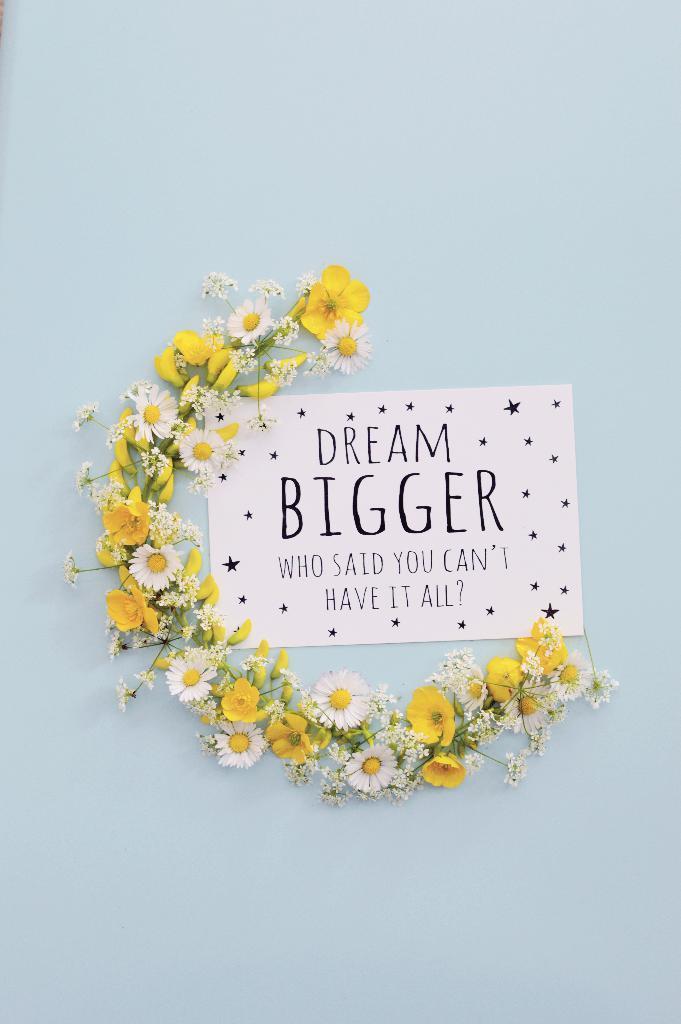Please provide a concise description of this image. In the foreground of this image, it seems like a wall on which a poster and a garland placed semicircle around the poster. 